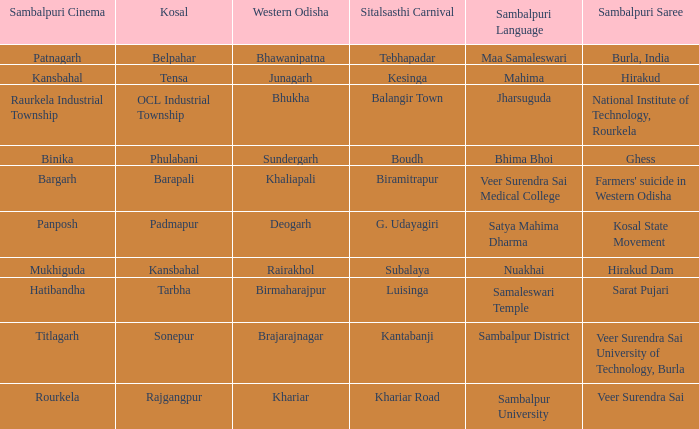What is the kosal with hatibandha as the sambalpuri cinema? Tarbha. Could you help me parse every detail presented in this table? {'header': ['Sambalpuri Cinema', 'Kosal', 'Western Odisha', 'Sitalsasthi Carnival', 'Sambalpuri Language', 'Sambalpuri Saree'], 'rows': [['Patnagarh', 'Belpahar', 'Bhawanipatna', 'Tebhapadar', 'Maa Samaleswari', 'Burla, India'], ['Kansbahal', 'Tensa', 'Junagarh', 'Kesinga', 'Mahima', 'Hirakud'], ['Raurkela Industrial Township', 'OCL Industrial Township', 'Bhukha', 'Balangir Town', 'Jharsuguda', 'National Institute of Technology, Rourkela'], ['Binika', 'Phulabani', 'Sundergarh', 'Boudh', 'Bhima Bhoi', 'Ghess'], ['Bargarh', 'Barapali', 'Khaliapali', 'Biramitrapur', 'Veer Surendra Sai Medical College', "Farmers' suicide in Western Odisha"], ['Panposh', 'Padmapur', 'Deogarh', 'G. Udayagiri', 'Satya Mahima Dharma', 'Kosal State Movement'], ['Mukhiguda', 'Kansbahal', 'Rairakhol', 'Subalaya', 'Nuakhai', 'Hirakud Dam'], ['Hatibandha', 'Tarbha', 'Birmaharajpur', 'Luisinga', 'Samaleswari Temple', 'Sarat Pujari'], ['Titlagarh', 'Sonepur', 'Brajarajnagar', 'Kantabanji', 'Sambalpur District', 'Veer Surendra Sai University of Technology, Burla'], ['Rourkela', 'Rajgangpur', 'Khariar', 'Khariar Road', 'Sambalpur University', 'Veer Surendra Sai']]} 